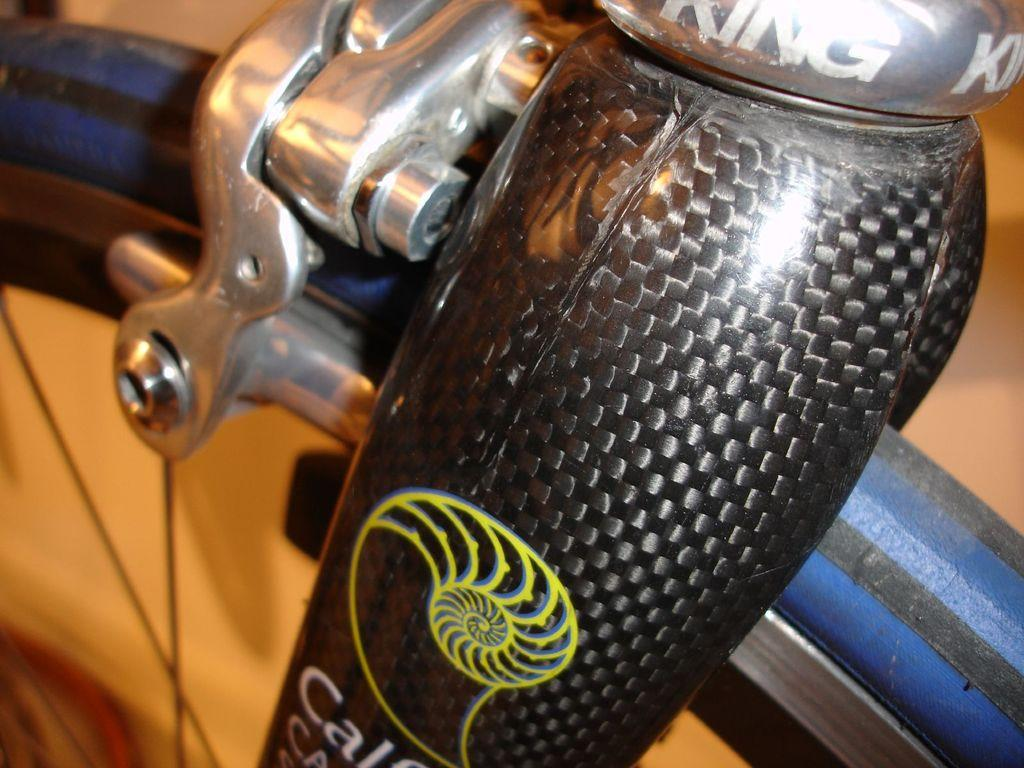What is the main subject of the image? The main subject of the image is a bicycle tire. Can you describe the bicycle tire in the image? The bicycle tire has visible parts, such as the rubber and the spokes. Is there any branding or identification on the bicycle tire? Yes, there is a logo on the bicycle tire. Are there any words or phrases written on the bicycle tire? Yes, text is written on the bicycle tire. What type of wool is used to make the bicycle tire in the image? There is no wool used in the construction of the bicycle tire; it is made of rubber and other materials. 